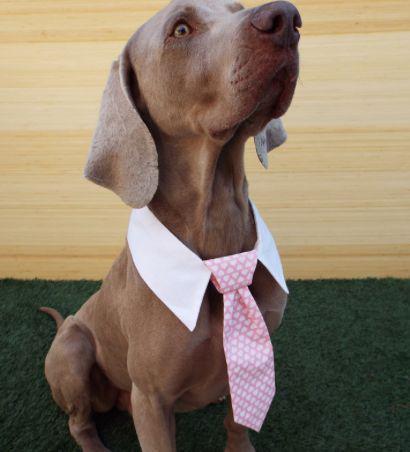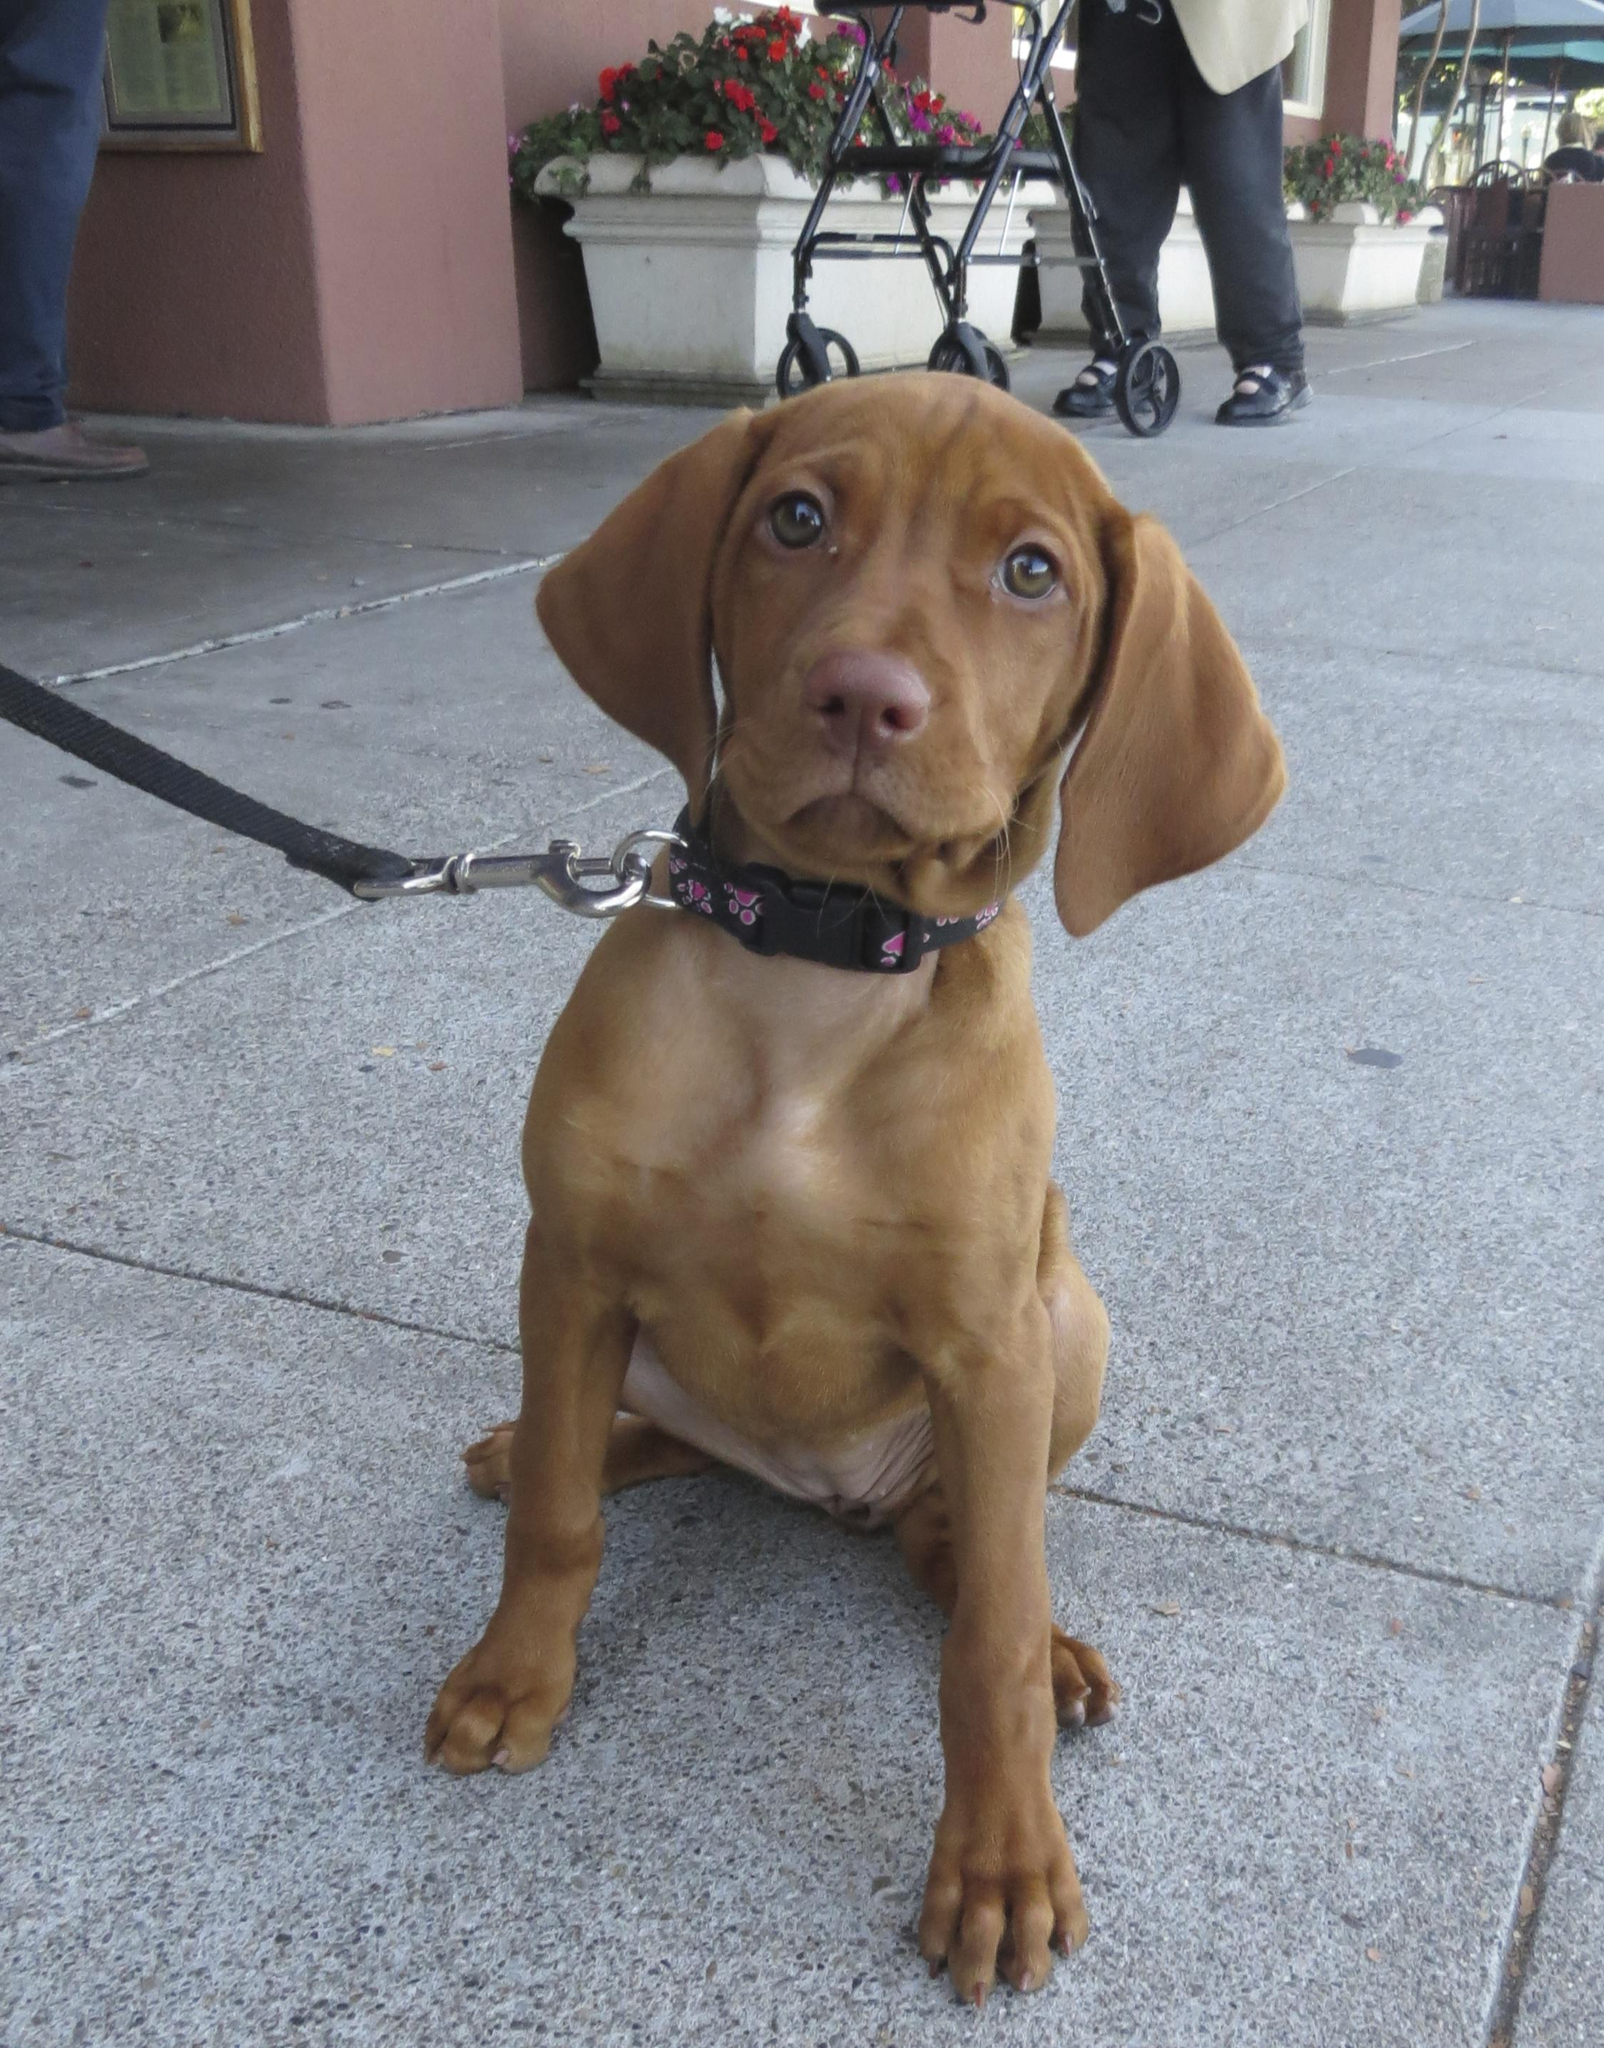The first image is the image on the left, the second image is the image on the right. For the images displayed, is the sentence "One dog is wearing a turtleneck shirt." factually correct? Answer yes or no. No. The first image is the image on the left, the second image is the image on the right. Analyze the images presented: Is the assertion "The dog on the right is reclining with front paws stretched in front of him and head raised, and the dog on the left is sitting uprgiht and wearing a pullover top." valid? Answer yes or no. No. 